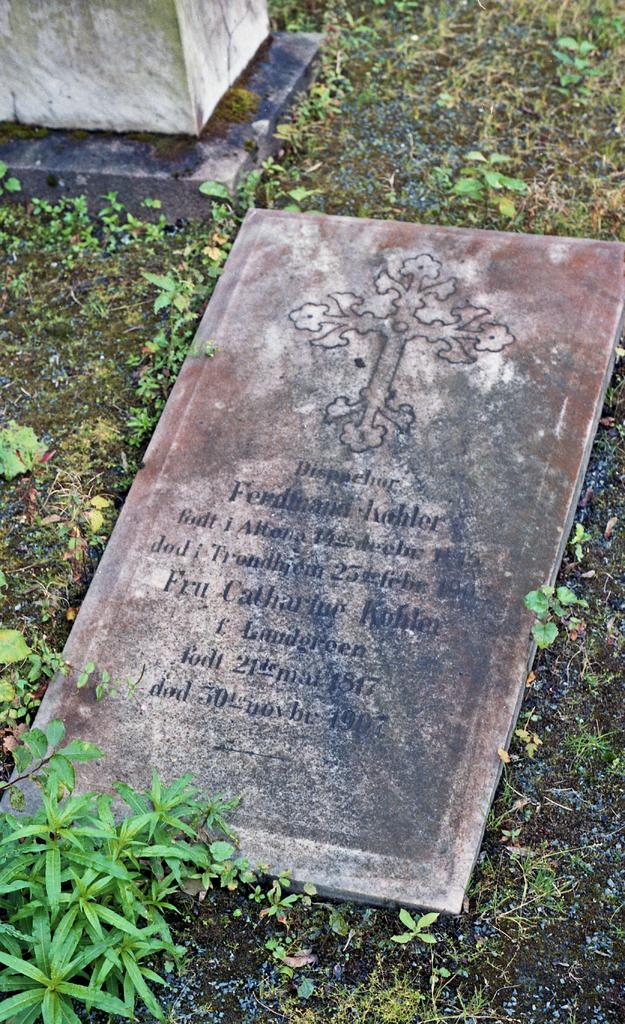What is the main subject of the image? There is a headstone in the image. What can be seen on the headstone? There is writing on the headstone. Can you describe the object in the left top corner of the image? Unfortunately, the facts provided do not give any information about the object in the left top corner. What type of vegetation is present in the image? There are plants on the ground in the image. What type of advertisement can be seen on the headstone? There is no advertisement present on the headstone; it has writing, but it is not an advertisement. How does the temper of the person affect the appearance of the headstone? The facts provided do not mention anything about the temper of a person, so we cannot determine how it might affect the appearance of the headstone. 